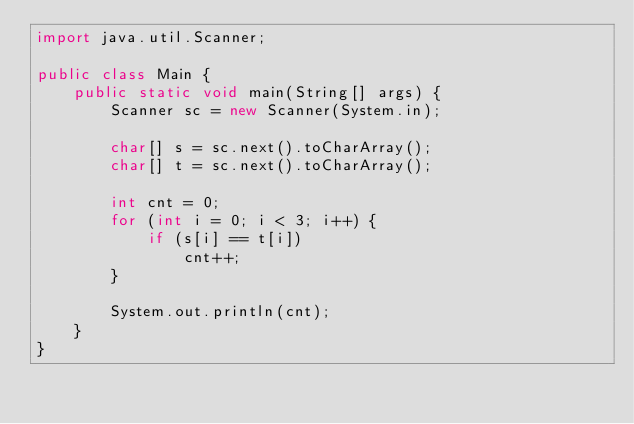Convert code to text. <code><loc_0><loc_0><loc_500><loc_500><_Java_>import java.util.Scanner;

public class Main {
    public static void main(String[] args) {
        Scanner sc = new Scanner(System.in);

        char[] s = sc.next().toCharArray();
        char[] t = sc.next().toCharArray();

        int cnt = 0;
        for (int i = 0; i < 3; i++) {
            if (s[i] == t[i])
                cnt++;
        }
        
        System.out.println(cnt);
    }
}</code> 